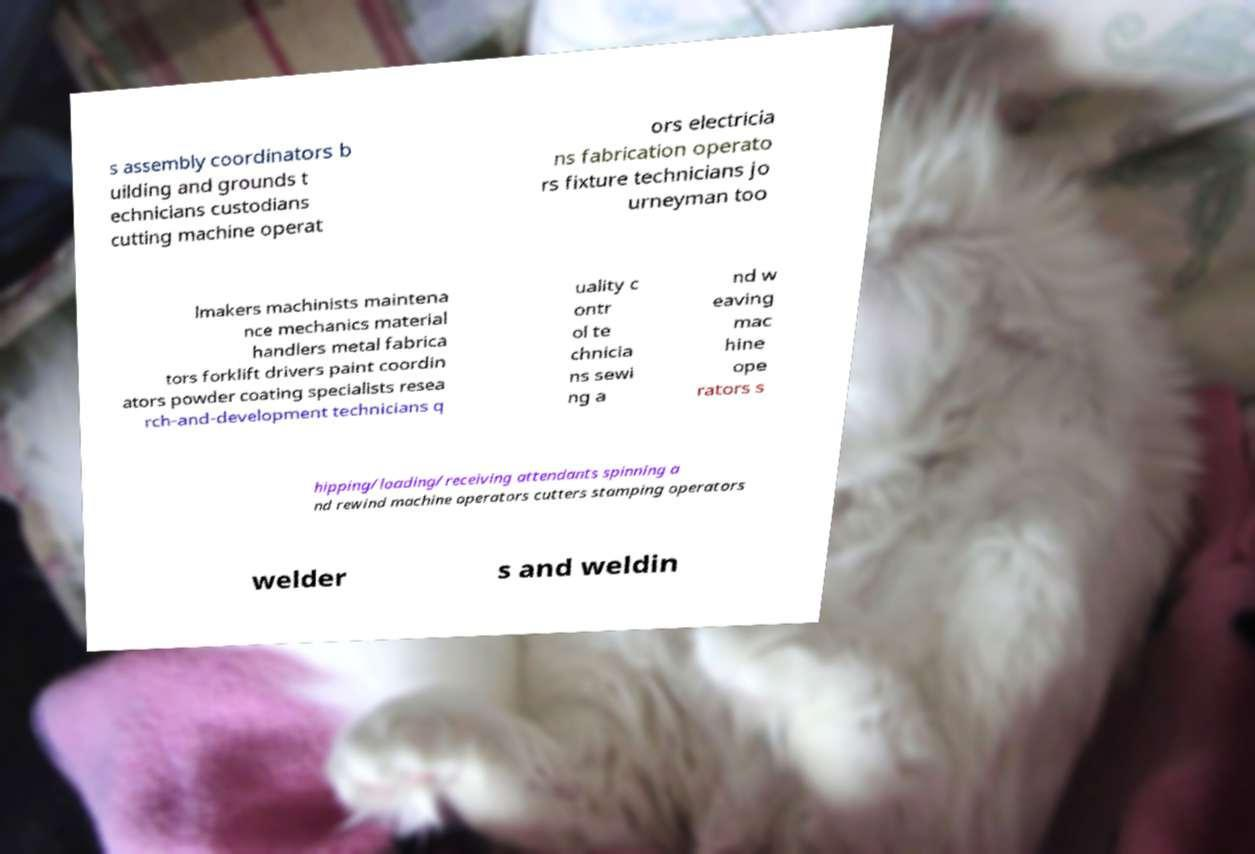Could you extract and type out the text from this image? s assembly coordinators b uilding and grounds t echnicians custodians cutting machine operat ors electricia ns fabrication operato rs fixture technicians jo urneyman too lmakers machinists maintena nce mechanics material handlers metal fabrica tors forklift drivers paint coordin ators powder coating specialists resea rch-and-development technicians q uality c ontr ol te chnicia ns sewi ng a nd w eaving mac hine ope rators s hipping/loading/receiving attendants spinning a nd rewind machine operators cutters stamping operators welder s and weldin 